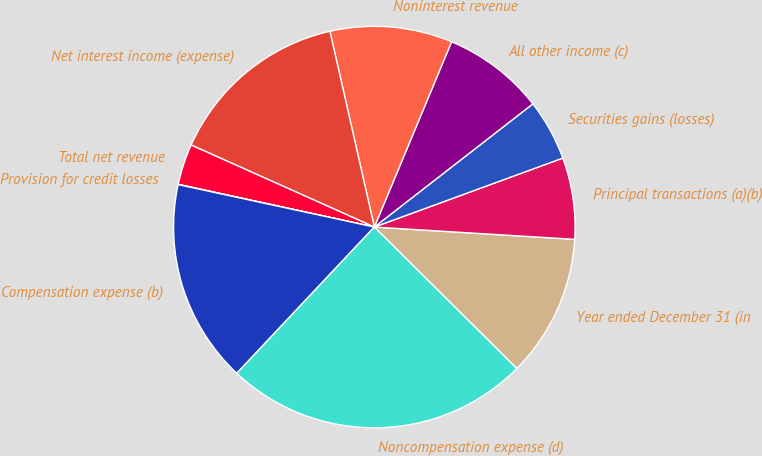<chart> <loc_0><loc_0><loc_500><loc_500><pie_chart><fcel>Year ended December 31 (in<fcel>Principal transactions (a)(b)<fcel>Securities gains (losses)<fcel>All other income (c)<fcel>Noninterest revenue<fcel>Net interest income (expense)<fcel>Total net revenue<fcel>Provision for credit losses<fcel>Compensation expense (b)<fcel>Noncompensation expense (d)<nl><fcel>11.47%<fcel>6.56%<fcel>4.93%<fcel>8.2%<fcel>9.84%<fcel>14.75%<fcel>3.29%<fcel>0.02%<fcel>16.38%<fcel>24.57%<nl></chart> 